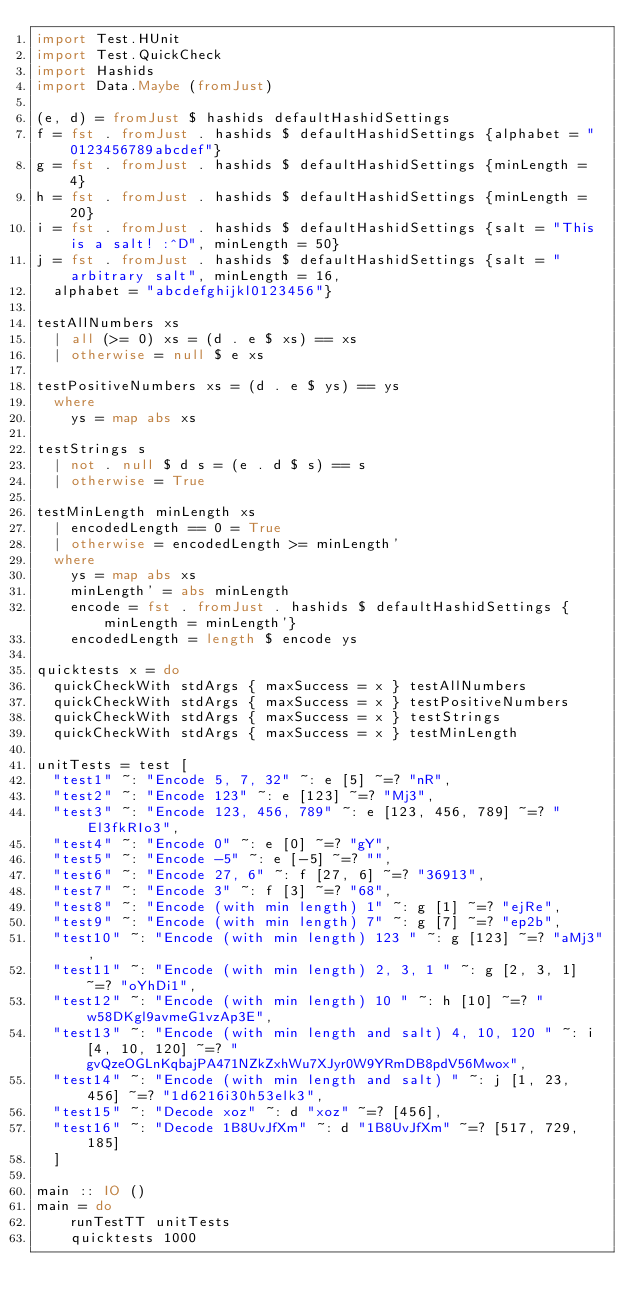Convert code to text. <code><loc_0><loc_0><loc_500><loc_500><_Haskell_>import Test.HUnit
import Test.QuickCheck
import Hashids
import Data.Maybe (fromJust)

(e, d) = fromJust $ hashids defaultHashidSettings
f = fst . fromJust . hashids $ defaultHashidSettings {alphabet = "0123456789abcdef"}
g = fst . fromJust . hashids $ defaultHashidSettings {minLength = 4}
h = fst . fromJust . hashids $ defaultHashidSettings {minLength = 20}
i = fst . fromJust . hashids $ defaultHashidSettings {salt = "This is a salt! :^D", minLength = 50}
j = fst . fromJust . hashids $ defaultHashidSettings {salt = "arbitrary salt", minLength = 16,
  alphabet = "abcdefghijkl0123456"}

testAllNumbers xs
  | all (>= 0) xs = (d . e $ xs) == xs
  | otherwise = null $ e xs

testPositiveNumbers xs = (d . e $ ys) == ys
  where
    ys = map abs xs

testStrings s
  | not . null $ d s = (e . d $ s) == s
  | otherwise = True

testMinLength minLength xs
  | encodedLength == 0 = True
  | otherwise = encodedLength >= minLength'
  where
    ys = map abs xs
    minLength' = abs minLength
    encode = fst . fromJust . hashids $ defaultHashidSettings {minLength = minLength'}
    encodedLength = length $ encode ys

quicktests x = do
  quickCheckWith stdArgs { maxSuccess = x } testAllNumbers
  quickCheckWith stdArgs { maxSuccess = x } testPositiveNumbers
  quickCheckWith stdArgs { maxSuccess = x } testStrings
  quickCheckWith stdArgs { maxSuccess = x } testMinLength

unitTests = test [
  "test1" ~: "Encode 5, 7, 32" ~: e [5] ~=? "nR",
  "test2" ~: "Encode 123" ~: e [123] ~=? "Mj3",
  "test3" ~: "Encode 123, 456, 789" ~: e [123, 456, 789] ~=? "El3fkRIo3",
  "test4" ~: "Encode 0" ~: e [0] ~=? "gY",
  "test5" ~: "Encode -5" ~: e [-5] ~=? "",
  "test6" ~: "Encode 27, 6" ~: f [27, 6] ~=? "36913",
  "test7" ~: "Encode 3" ~: f [3] ~=? "68",
  "test8" ~: "Encode (with min length) 1" ~: g [1] ~=? "ejRe",
  "test9" ~: "Encode (with min length) 7" ~: g [7] ~=? "ep2b",
  "test10" ~: "Encode (with min length) 123 " ~: g [123] ~=? "aMj3",
  "test11" ~: "Encode (with min length) 2, 3, 1 " ~: g [2, 3, 1] ~=? "oYhDi1",
  "test12" ~: "Encode (with min length) 10 " ~: h [10] ~=? "w58DKgl9avmeG1vzAp3E",
  "test13" ~: "Encode (with min length and salt) 4, 10, 120 " ~: i [4, 10, 120] ~=? "gvQzeOGLnKqbajPA471NZkZxhWu7XJyr0W9YRmDB8pdV56Mwox",
  "test14" ~: "Encode (with min length and salt) " ~: j [1, 23, 456] ~=? "1d6216i30h53elk3",
  "test15" ~: "Decode xoz" ~: d "xoz" ~=? [456],
  "test16" ~: "Decode 1B8UvJfXm" ~: d "1B8UvJfXm" ~=? [517, 729, 185]
  ]

main :: IO ()
main = do
    runTestTT unitTests
    quicktests 1000

</code> 